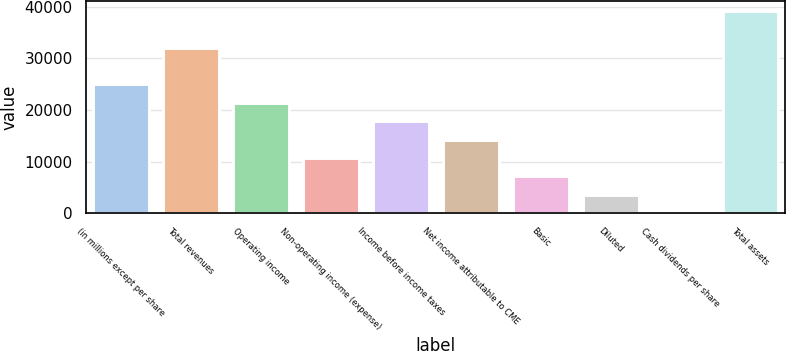Convert chart to OTSL. <chart><loc_0><loc_0><loc_500><loc_500><bar_chart><fcel>(in millions except per share<fcel>Total revenues<fcel>Operating income<fcel>Non-operating income (expense)<fcel>Income before income taxes<fcel>Net income attributable to CME<fcel>Basic<fcel>Diluted<fcel>Cash dividends per share<fcel>Total assets<nl><fcel>24956<fcel>32086<fcel>21391<fcel>10696<fcel>17826<fcel>14261<fcel>7130.94<fcel>3565.93<fcel>0.92<fcel>39216<nl></chart> 